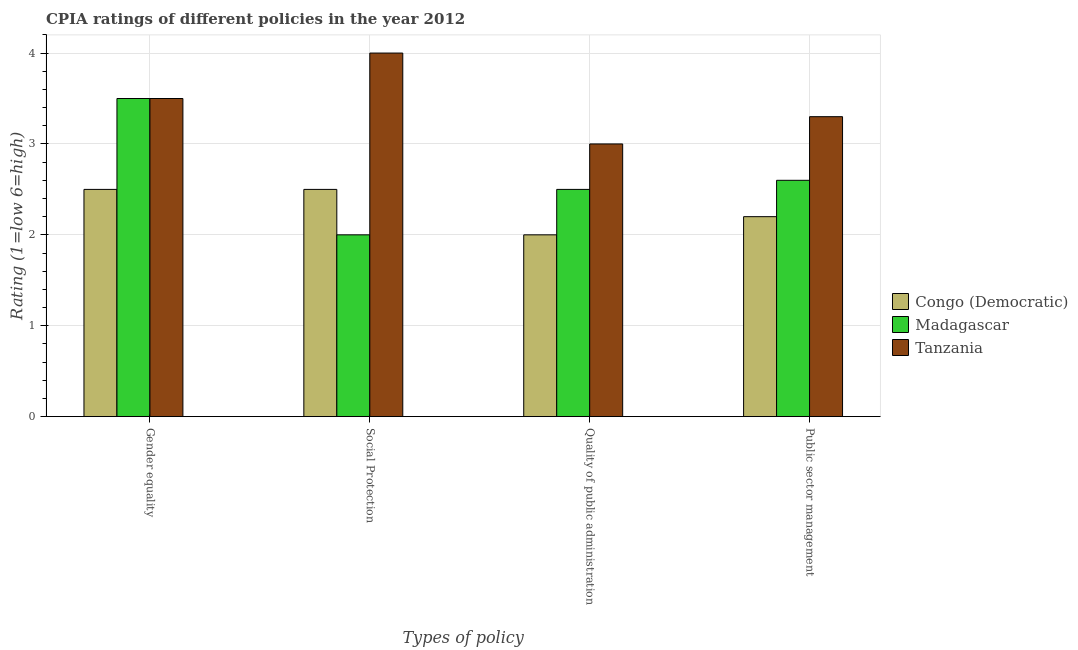How many different coloured bars are there?
Your answer should be very brief. 3. How many groups of bars are there?
Make the answer very short. 4. What is the label of the 4th group of bars from the left?
Provide a short and direct response. Public sector management. What is the cpia rating of public sector management in Madagascar?
Your response must be concise. 2.6. Across all countries, what is the minimum cpia rating of quality of public administration?
Keep it short and to the point. 2. In which country was the cpia rating of gender equality maximum?
Your answer should be very brief. Madagascar. In which country was the cpia rating of gender equality minimum?
Make the answer very short. Congo (Democratic). What is the difference between the cpia rating of social protection in Tanzania and the cpia rating of quality of public administration in Madagascar?
Your response must be concise. 1.5. What is the average cpia rating of social protection per country?
Offer a very short reply. 2.83. What is the difference between the cpia rating of social protection and cpia rating of public sector management in Congo (Democratic)?
Give a very brief answer. 0.3. In how many countries, is the cpia rating of gender equality greater than 2.6 ?
Your answer should be compact. 2. Is the difference between the cpia rating of public sector management in Congo (Democratic) and Madagascar greater than the difference between the cpia rating of social protection in Congo (Democratic) and Madagascar?
Provide a succinct answer. No. In how many countries, is the cpia rating of social protection greater than the average cpia rating of social protection taken over all countries?
Your response must be concise. 1. Is it the case that in every country, the sum of the cpia rating of gender equality and cpia rating of public sector management is greater than the sum of cpia rating of social protection and cpia rating of quality of public administration?
Your answer should be compact. Yes. What does the 2nd bar from the left in Quality of public administration represents?
Offer a terse response. Madagascar. What does the 1st bar from the right in Gender equality represents?
Offer a very short reply. Tanzania. How many bars are there?
Your answer should be compact. 12. Are the values on the major ticks of Y-axis written in scientific E-notation?
Give a very brief answer. No. How many legend labels are there?
Your answer should be very brief. 3. What is the title of the graph?
Provide a succinct answer. CPIA ratings of different policies in the year 2012. What is the label or title of the X-axis?
Give a very brief answer. Types of policy. What is the Rating (1=low 6=high) of Congo (Democratic) in Gender equality?
Your response must be concise. 2.5. What is the Rating (1=low 6=high) in Tanzania in Gender equality?
Your answer should be compact. 3.5. What is the Rating (1=low 6=high) of Congo (Democratic) in Quality of public administration?
Make the answer very short. 2. What is the Rating (1=low 6=high) in Congo (Democratic) in Public sector management?
Offer a terse response. 2.2. Across all Types of policy, what is the maximum Rating (1=low 6=high) of Madagascar?
Give a very brief answer. 3.5. Across all Types of policy, what is the minimum Rating (1=low 6=high) in Congo (Democratic)?
Your answer should be very brief. 2. Across all Types of policy, what is the minimum Rating (1=low 6=high) in Madagascar?
Keep it short and to the point. 2. What is the total Rating (1=low 6=high) of Madagascar in the graph?
Your answer should be compact. 10.6. What is the total Rating (1=low 6=high) in Tanzania in the graph?
Offer a very short reply. 13.8. What is the difference between the Rating (1=low 6=high) of Madagascar in Gender equality and that in Social Protection?
Provide a succinct answer. 1.5. What is the difference between the Rating (1=low 6=high) of Congo (Democratic) in Gender equality and that in Quality of public administration?
Give a very brief answer. 0.5. What is the difference between the Rating (1=low 6=high) in Congo (Democratic) in Gender equality and that in Public sector management?
Provide a short and direct response. 0.3. What is the difference between the Rating (1=low 6=high) of Madagascar in Gender equality and that in Public sector management?
Give a very brief answer. 0.9. What is the difference between the Rating (1=low 6=high) of Congo (Democratic) in Social Protection and that in Quality of public administration?
Your answer should be compact. 0.5. What is the difference between the Rating (1=low 6=high) in Congo (Democratic) in Social Protection and that in Public sector management?
Give a very brief answer. 0.3. What is the difference between the Rating (1=low 6=high) of Madagascar in Social Protection and that in Public sector management?
Your answer should be very brief. -0.6. What is the difference between the Rating (1=low 6=high) in Tanzania in Quality of public administration and that in Public sector management?
Your response must be concise. -0.3. What is the difference between the Rating (1=low 6=high) in Congo (Democratic) in Gender equality and the Rating (1=low 6=high) in Madagascar in Social Protection?
Give a very brief answer. 0.5. What is the difference between the Rating (1=low 6=high) of Congo (Democratic) in Gender equality and the Rating (1=low 6=high) of Tanzania in Social Protection?
Your answer should be very brief. -1.5. What is the difference between the Rating (1=low 6=high) in Congo (Democratic) in Gender equality and the Rating (1=low 6=high) in Tanzania in Quality of public administration?
Your response must be concise. -0.5. What is the difference between the Rating (1=low 6=high) in Madagascar in Gender equality and the Rating (1=low 6=high) in Tanzania in Quality of public administration?
Keep it short and to the point. 0.5. What is the difference between the Rating (1=low 6=high) in Congo (Democratic) in Gender equality and the Rating (1=low 6=high) in Madagascar in Public sector management?
Offer a very short reply. -0.1. What is the difference between the Rating (1=low 6=high) in Congo (Democratic) in Gender equality and the Rating (1=low 6=high) in Tanzania in Public sector management?
Provide a short and direct response. -0.8. What is the difference between the Rating (1=low 6=high) in Madagascar in Gender equality and the Rating (1=low 6=high) in Tanzania in Public sector management?
Offer a terse response. 0.2. What is the difference between the Rating (1=low 6=high) of Congo (Democratic) in Social Protection and the Rating (1=low 6=high) of Madagascar in Quality of public administration?
Your response must be concise. 0. What is the difference between the Rating (1=low 6=high) in Congo (Democratic) in Social Protection and the Rating (1=low 6=high) in Madagascar in Public sector management?
Make the answer very short. -0.1. What is the difference between the Rating (1=low 6=high) in Congo (Democratic) in Quality of public administration and the Rating (1=low 6=high) in Madagascar in Public sector management?
Your response must be concise. -0.6. What is the average Rating (1=low 6=high) in Madagascar per Types of policy?
Your response must be concise. 2.65. What is the average Rating (1=low 6=high) of Tanzania per Types of policy?
Your answer should be very brief. 3.45. What is the difference between the Rating (1=low 6=high) in Congo (Democratic) and Rating (1=low 6=high) in Tanzania in Gender equality?
Make the answer very short. -1. What is the difference between the Rating (1=low 6=high) of Congo (Democratic) and Rating (1=low 6=high) of Madagascar in Social Protection?
Make the answer very short. 0.5. What is the difference between the Rating (1=low 6=high) in Congo (Democratic) and Rating (1=low 6=high) in Tanzania in Social Protection?
Provide a succinct answer. -1.5. What is the difference between the Rating (1=low 6=high) in Congo (Democratic) and Rating (1=low 6=high) in Tanzania in Quality of public administration?
Your answer should be compact. -1. What is the difference between the Rating (1=low 6=high) in Congo (Democratic) and Rating (1=low 6=high) in Tanzania in Public sector management?
Provide a short and direct response. -1.1. What is the difference between the Rating (1=low 6=high) in Madagascar and Rating (1=low 6=high) in Tanzania in Public sector management?
Provide a short and direct response. -0.7. What is the ratio of the Rating (1=low 6=high) of Madagascar in Gender equality to that in Social Protection?
Your answer should be very brief. 1.75. What is the ratio of the Rating (1=low 6=high) in Tanzania in Gender equality to that in Social Protection?
Your response must be concise. 0.88. What is the ratio of the Rating (1=low 6=high) in Madagascar in Gender equality to that in Quality of public administration?
Your response must be concise. 1.4. What is the ratio of the Rating (1=low 6=high) of Tanzania in Gender equality to that in Quality of public administration?
Your answer should be compact. 1.17. What is the ratio of the Rating (1=low 6=high) of Congo (Democratic) in Gender equality to that in Public sector management?
Ensure brevity in your answer.  1.14. What is the ratio of the Rating (1=low 6=high) of Madagascar in Gender equality to that in Public sector management?
Give a very brief answer. 1.35. What is the ratio of the Rating (1=low 6=high) in Tanzania in Gender equality to that in Public sector management?
Provide a short and direct response. 1.06. What is the ratio of the Rating (1=low 6=high) of Madagascar in Social Protection to that in Quality of public administration?
Keep it short and to the point. 0.8. What is the ratio of the Rating (1=low 6=high) in Tanzania in Social Protection to that in Quality of public administration?
Make the answer very short. 1.33. What is the ratio of the Rating (1=low 6=high) in Congo (Democratic) in Social Protection to that in Public sector management?
Ensure brevity in your answer.  1.14. What is the ratio of the Rating (1=low 6=high) of Madagascar in Social Protection to that in Public sector management?
Your answer should be very brief. 0.77. What is the ratio of the Rating (1=low 6=high) of Tanzania in Social Protection to that in Public sector management?
Ensure brevity in your answer.  1.21. What is the ratio of the Rating (1=low 6=high) of Congo (Democratic) in Quality of public administration to that in Public sector management?
Offer a terse response. 0.91. What is the ratio of the Rating (1=low 6=high) of Madagascar in Quality of public administration to that in Public sector management?
Give a very brief answer. 0.96. What is the ratio of the Rating (1=low 6=high) of Tanzania in Quality of public administration to that in Public sector management?
Make the answer very short. 0.91. What is the difference between the highest and the second highest Rating (1=low 6=high) of Madagascar?
Your response must be concise. 0.9. What is the difference between the highest and the lowest Rating (1=low 6=high) in Madagascar?
Provide a short and direct response. 1.5. What is the difference between the highest and the lowest Rating (1=low 6=high) of Tanzania?
Give a very brief answer. 1. 